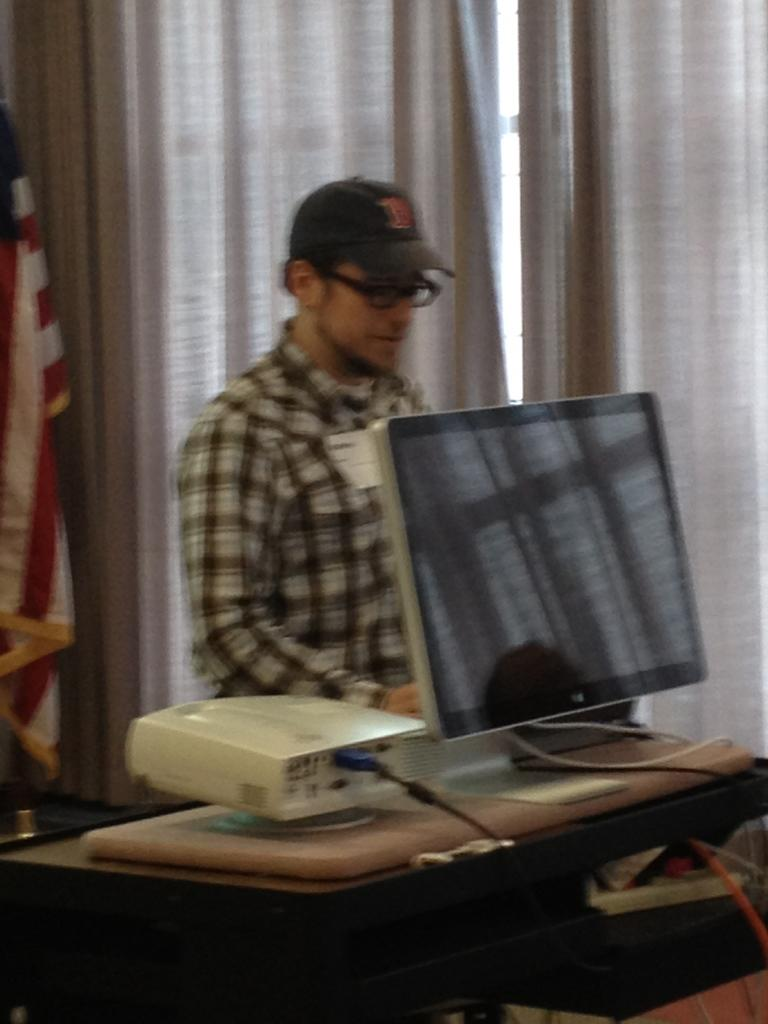Who is present in the image? There is a man in the image. What is the man doing in the image? The man is standing in the image. What accessories is the man wearing in the image? The man is wearing a cap and spectacles in the image. What is in front of the man in the image? There is a system in front of the man in the image. What can be seen behind the man in the image? There is a flag of a country behind the man in the image. What type of oil can be seen leaking from the train in the image? There is no train present in the image, so there is no oil leak to observe. 